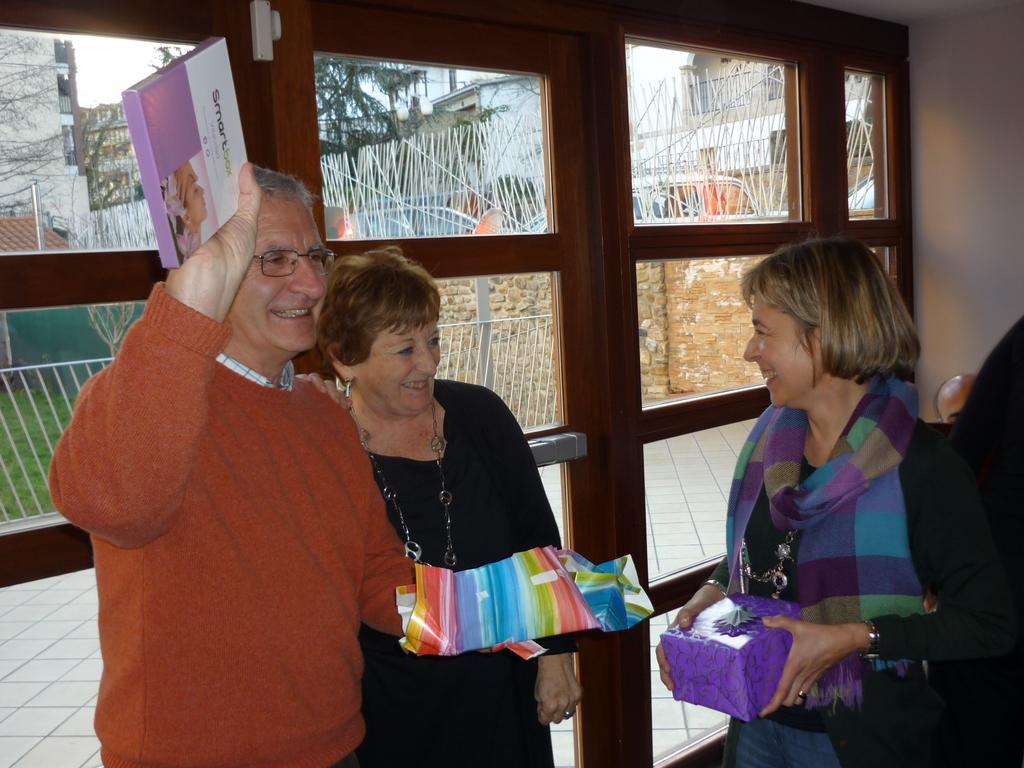In one or two sentences, can you explain what this image depicts? On the right side of the image we can see a lady standing and holding a box in her hand. On the left there is a man and a lady standing and smiling. In the background there is a door and a wall. 